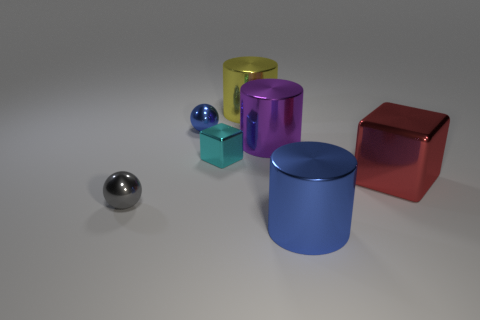Add 1 large blue metal objects. How many objects exist? 8 Subtract all blocks. How many objects are left? 5 Add 1 large purple shiny things. How many large purple shiny things exist? 2 Subtract 1 red cubes. How many objects are left? 6 Subtract all large shiny objects. Subtract all big purple rubber cylinders. How many objects are left? 3 Add 2 gray things. How many gray things are left? 3 